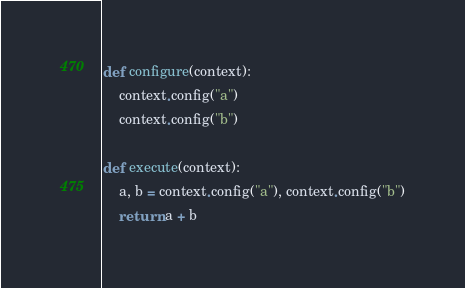Convert code to text. <code><loc_0><loc_0><loc_500><loc_500><_Python_>def configure(context):
    context.config("a")
    context.config("b")

def execute(context):
    a, b = context.config("a"), context.config("b")
    return a + b
</code> 